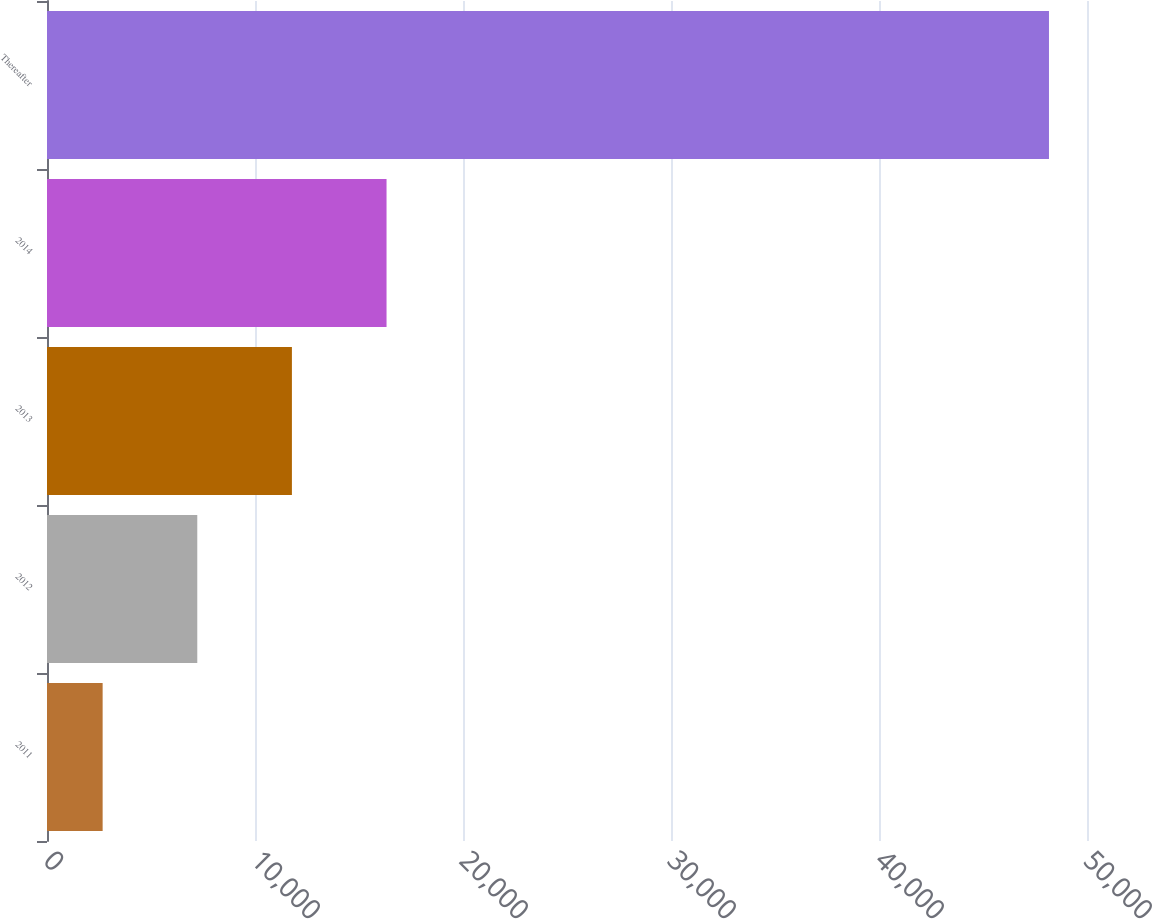Convert chart. <chart><loc_0><loc_0><loc_500><loc_500><bar_chart><fcel>2011<fcel>2012<fcel>2013<fcel>2014<fcel>Thereafter<nl><fcel>2675<fcel>7224.7<fcel>11774.4<fcel>16324.1<fcel>48172<nl></chart> 